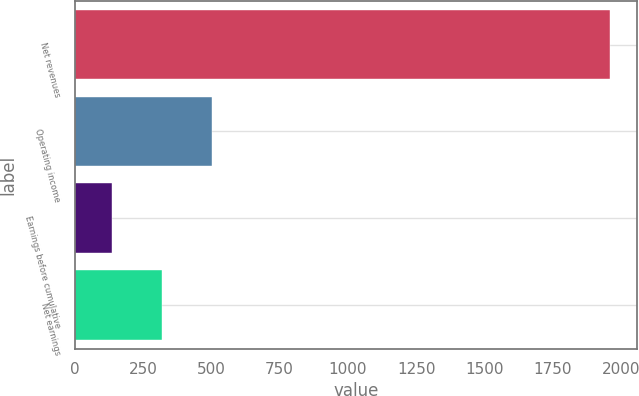Convert chart to OTSL. <chart><loc_0><loc_0><loc_500><loc_500><bar_chart><fcel>Net revenues<fcel>Operating income<fcel>Earnings before cumulative<fcel>Net earnings<nl><fcel>1961<fcel>501.72<fcel>136.9<fcel>319.31<nl></chart> 